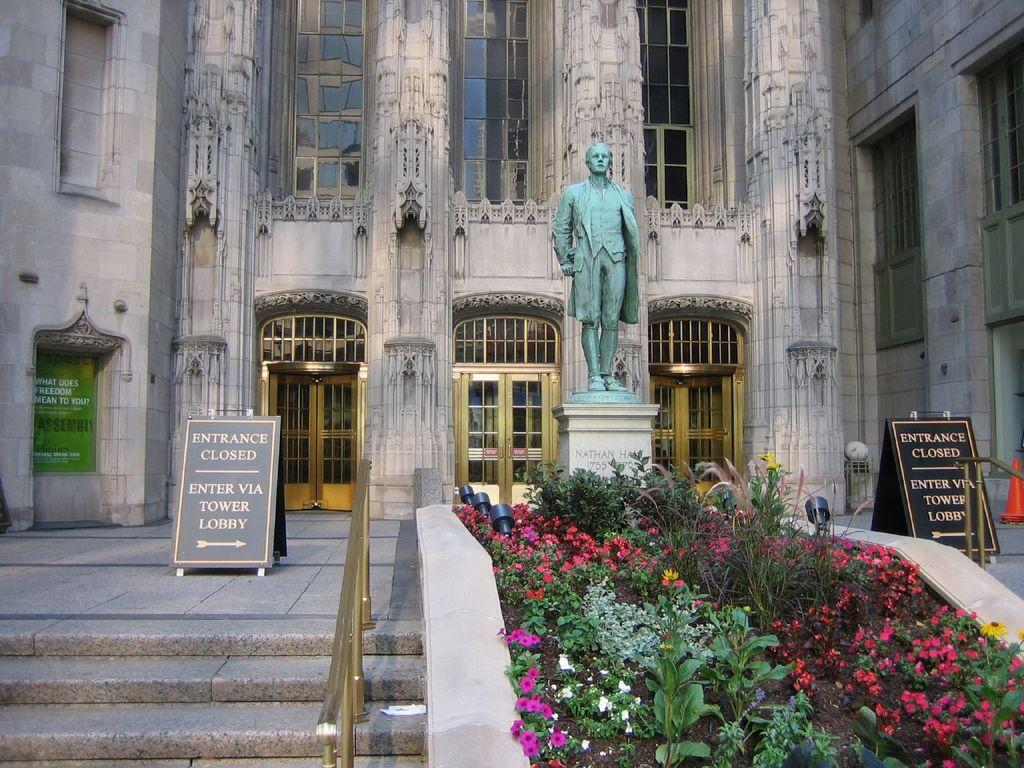What type of living organisms can be seen in the image? Plants can be seen in the image. What is the arrangement of the boards in relation to the plants? There are boards on the left and right sides of the plants. What is located behind the plants? There is a statue behind the plants. What type of structure is visible in the image? There is a building with doors in the image. Can you see a girl wearing a veil in the image? There is no girl wearing a veil present in the image. 